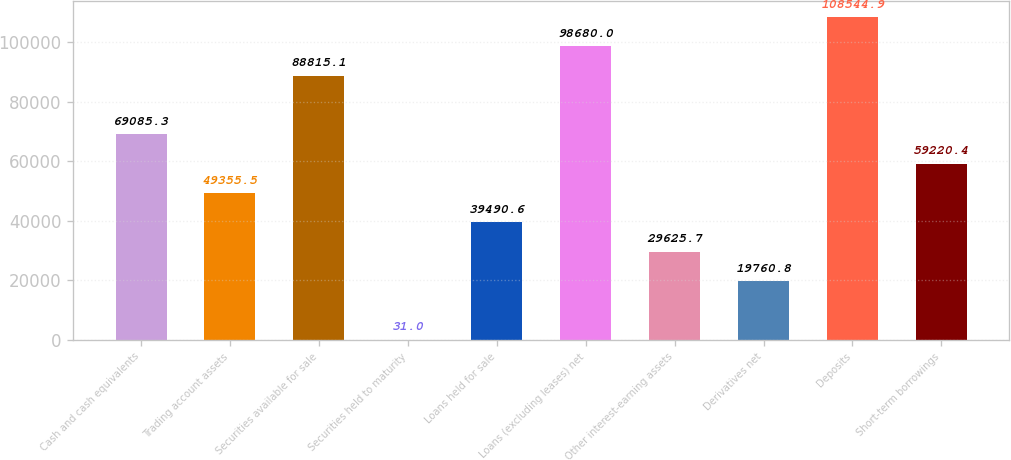Convert chart to OTSL. <chart><loc_0><loc_0><loc_500><loc_500><bar_chart><fcel>Cash and cash equivalents<fcel>Trading account assets<fcel>Securities available for sale<fcel>Securities held to maturity<fcel>Loans held for sale<fcel>Loans (excluding leases) net<fcel>Other interest-earning assets<fcel>Derivatives net<fcel>Deposits<fcel>Short-term borrowings<nl><fcel>69085.3<fcel>49355.5<fcel>88815.1<fcel>31<fcel>39490.6<fcel>98680<fcel>29625.7<fcel>19760.8<fcel>108545<fcel>59220.4<nl></chart> 